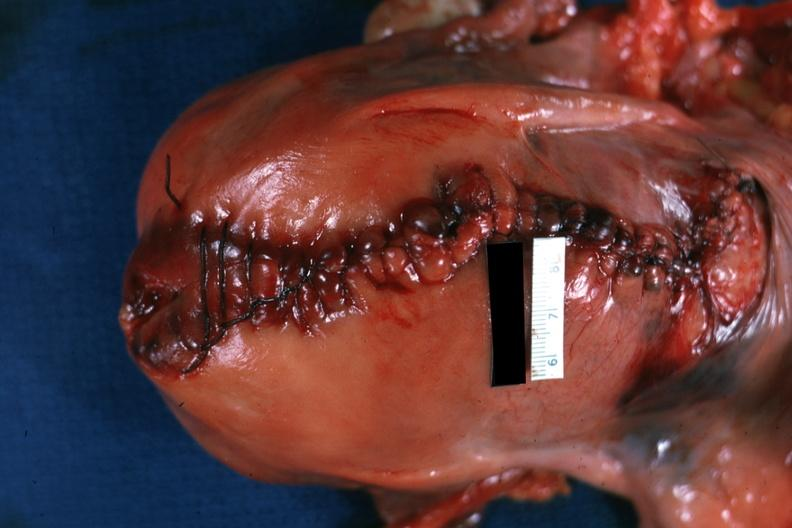what is present?
Answer the question using a single word or phrase. Female reproductive 